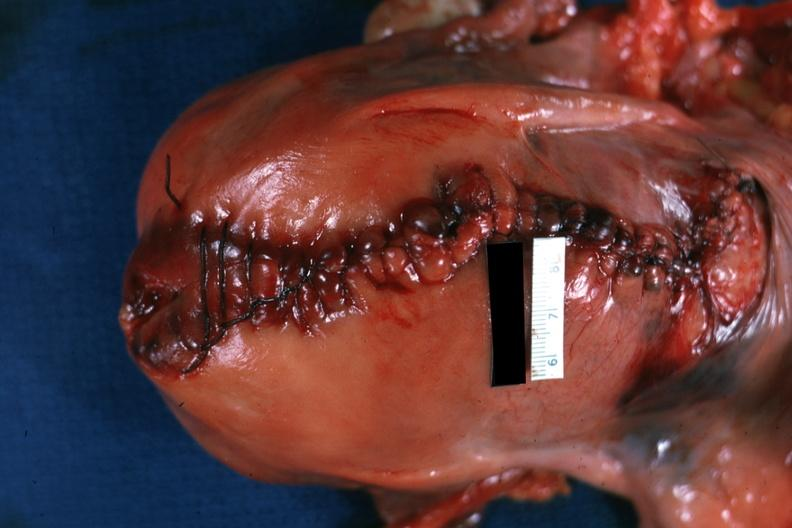what is present?
Answer the question using a single word or phrase. Female reproductive 